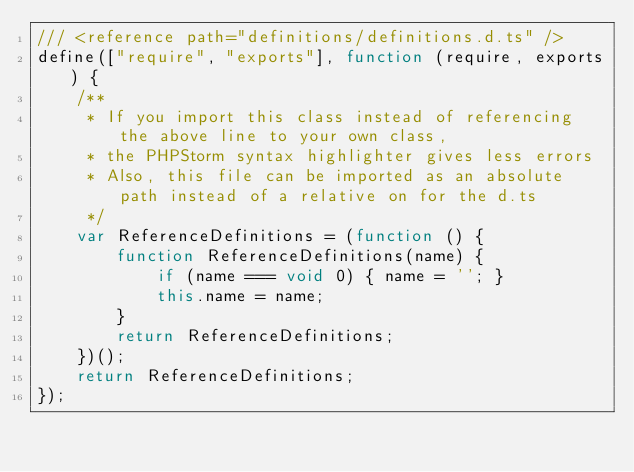Convert code to text. <code><loc_0><loc_0><loc_500><loc_500><_JavaScript_>/// <reference path="definitions/definitions.d.ts" />
define(["require", "exports"], function (require, exports) {
    /**
     * If you import this class instead of referencing the above line to your own class,
     * the PHPStorm syntax highlighter gives less errors
     * Also, this file can be imported as an absolute path instead of a relative on for the d.ts
     */
    var ReferenceDefinitions = (function () {
        function ReferenceDefinitions(name) {
            if (name === void 0) { name = ''; }
            this.name = name;
        }
        return ReferenceDefinitions;
    })();
    return ReferenceDefinitions;
});
</code> 